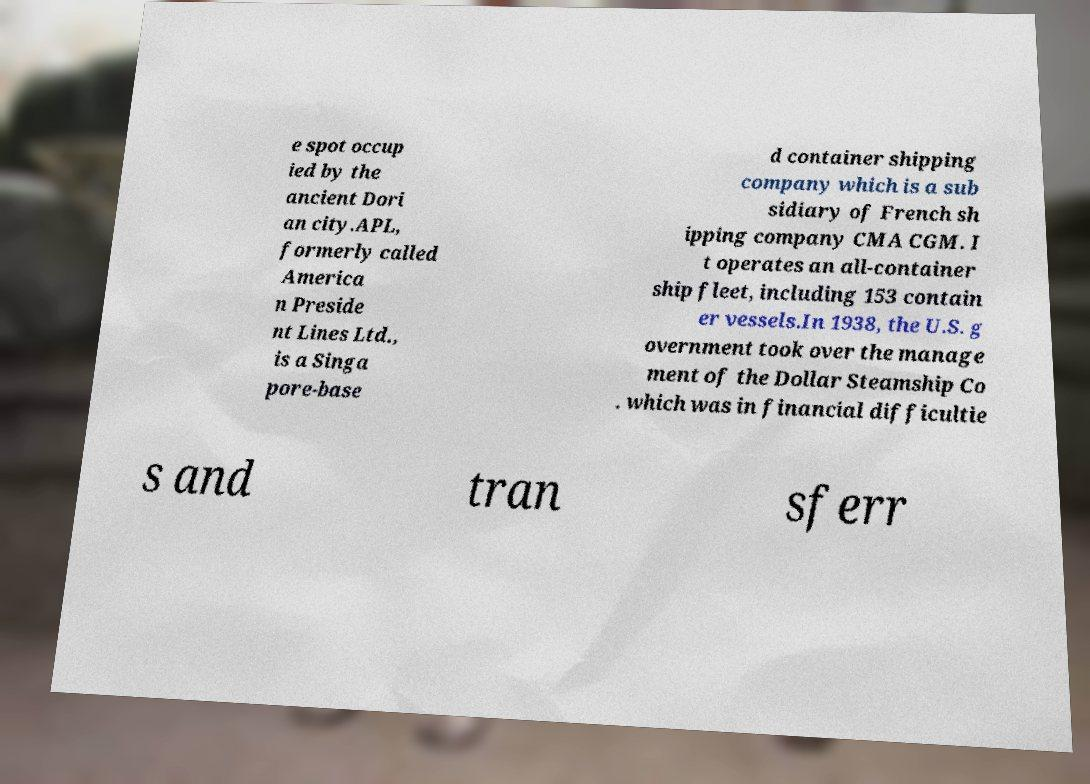Can you read and provide the text displayed in the image?This photo seems to have some interesting text. Can you extract and type it out for me? e spot occup ied by the ancient Dori an city.APL, formerly called America n Preside nt Lines Ltd., is a Singa pore-base d container shipping company which is a sub sidiary of French sh ipping company CMA CGM. I t operates an all-container ship fleet, including 153 contain er vessels.In 1938, the U.S. g overnment took over the manage ment of the Dollar Steamship Co . which was in financial difficultie s and tran sferr 